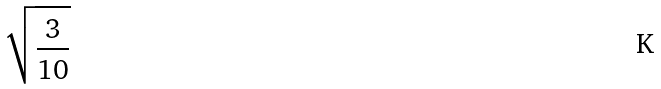Convert formula to latex. <formula><loc_0><loc_0><loc_500><loc_500>\sqrt { \frac { 3 } { 1 0 } }</formula> 